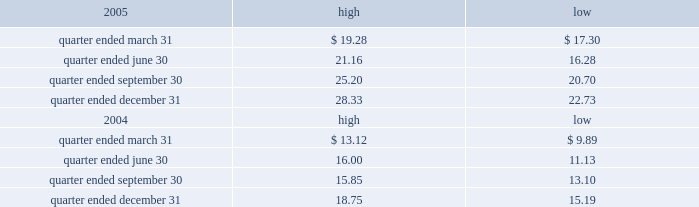Part ii item 5 .
Market for registrant 2019s common equity , related stockholder matters and issuer purchases of equity securities the table presents reported quarterly high and low per share sale prices of our class a common stock on the new york stock exchange ( nyse ) for the years 2005 and 2004. .
On march 9 , 2006 , the closing price of our class a common stock was $ 29.83 per share as reported on the nyse .
As of march 9 , 2006 , we had 419677495 outstanding shares of class a common stock and 687 registered holders .
In february 2004 , all outstanding shares of our class b common stock were converted into shares of our class a common stock on a one-for-one basis pursuant to the occurrence of the 201cdodge conversion event 201d as defined in our charter .
Also in february 2004 , all outstanding shares of class c common stock were converted into shares of class a common stock on a one-for-one basis .
In august 2005 , we amended and restated our charter to , among other things , eliminate our class b common stock and class c common stock .
The information under 201csecurities authorized for issuance under equity compensation plans 201d from the definitive proxy statement is hereby incorporated by reference into item 12 of this annual report .
Dividends we have never paid a dividend on any class of our common stock .
We anticipate that we may retain future earnings , if any , to fund the development and growth of our business .
The indentures governing our 7.50% ( 7.50 % ) senior notes due 2012 ( 7.50% ( 7.50 % ) notes ) and our 7.125% ( 7.125 % ) senior notes due 2012 ( 7.125% ( 7.125 % ) notes ) may prohibit us from paying dividends to our stockholders unless we satisfy certain financial covenants .
Our credit facilities and the indentures governing the terms of our debt securities contain covenants that may restrict the ability of our subsidiaries from making to us any direct or indirect distribution , dividend or other payment on account of their limited liability company interests , partnership interests , capital stock or other equity interests .
Under our credit facilities , the borrower subsidiaries may pay cash dividends or make other distributions to us in accordance with the applicable credit facility only if no default exists or would be created thereby .
The indenture governing the terms of the ati 7.25% ( 7.25 % ) senior subordinated notes due 2011 ( ati 7.25% ( 7.25 % ) notes ) prohibit ati and certain of our other subsidiaries that have guaranteed those notes ( sister guarantors ) from paying dividends and making other payments or distributions to us unless certain financial covenants are satisfied .
The indentures governing the terms of our 7.50% ( 7.50 % ) notes and 7.125% ( 7.125 % ) notes also contain certain restrictive covenants , which prohibit the restricted subsidiaries under these indentures from paying dividends and making other payments or distributions to us unless certain financial covenants are satisfied .
For more information about the restrictions under our credit facilities and our notes indentures , see note 7 to our consolidated financial statements included in this annual report and the section entitled 201cmanagement 2019s .
What is the growth rate in the common stock price from the highest price during quarter ended september 31 of 2005 to the highest price during quarter ended september 31 of 2006? 
Computations: ((25.20 - 15.85) / 15.85)
Answer: 0.58991. Part ii item 5 .
Market for registrant 2019s common equity , related stockholder matters and issuer purchases of equity securities the table presents reported quarterly high and low per share sale prices of our class a common stock on the new york stock exchange ( nyse ) for the years 2005 and 2004. .
On march 9 , 2006 , the closing price of our class a common stock was $ 29.83 per share as reported on the nyse .
As of march 9 , 2006 , we had 419677495 outstanding shares of class a common stock and 687 registered holders .
In february 2004 , all outstanding shares of our class b common stock were converted into shares of our class a common stock on a one-for-one basis pursuant to the occurrence of the 201cdodge conversion event 201d as defined in our charter .
Also in february 2004 , all outstanding shares of class c common stock were converted into shares of class a common stock on a one-for-one basis .
In august 2005 , we amended and restated our charter to , among other things , eliminate our class b common stock and class c common stock .
The information under 201csecurities authorized for issuance under equity compensation plans 201d from the definitive proxy statement is hereby incorporated by reference into item 12 of this annual report .
Dividends we have never paid a dividend on any class of our common stock .
We anticipate that we may retain future earnings , if any , to fund the development and growth of our business .
The indentures governing our 7.50% ( 7.50 % ) senior notes due 2012 ( 7.50% ( 7.50 % ) notes ) and our 7.125% ( 7.125 % ) senior notes due 2012 ( 7.125% ( 7.125 % ) notes ) may prohibit us from paying dividends to our stockholders unless we satisfy certain financial covenants .
Our credit facilities and the indentures governing the terms of our debt securities contain covenants that may restrict the ability of our subsidiaries from making to us any direct or indirect distribution , dividend or other payment on account of their limited liability company interests , partnership interests , capital stock or other equity interests .
Under our credit facilities , the borrower subsidiaries may pay cash dividends or make other distributions to us in accordance with the applicable credit facility only if no default exists or would be created thereby .
The indenture governing the terms of the ati 7.25% ( 7.25 % ) senior subordinated notes due 2011 ( ati 7.25% ( 7.25 % ) notes ) prohibit ati and certain of our other subsidiaries that have guaranteed those notes ( sister guarantors ) from paying dividends and making other payments or distributions to us unless certain financial covenants are satisfied .
The indentures governing the terms of our 7.50% ( 7.50 % ) notes and 7.125% ( 7.125 % ) notes also contain certain restrictive covenants , which prohibit the restricted subsidiaries under these indentures from paying dividends and making other payments or distributions to us unless certain financial covenants are satisfied .
For more information about the restrictions under our credit facilities and our notes indentures , see note 7 to our consolidated financial statements included in this annual report and the section entitled 201cmanagement 2019s .
In 2005 for the quarter ended june 30 what was the percent of the change in the class a common stock on the new york stock exchange from highest to lowest price? 
Computations: ((21.16 - 16.28) / 16.28)
Answer: 0.29975. 